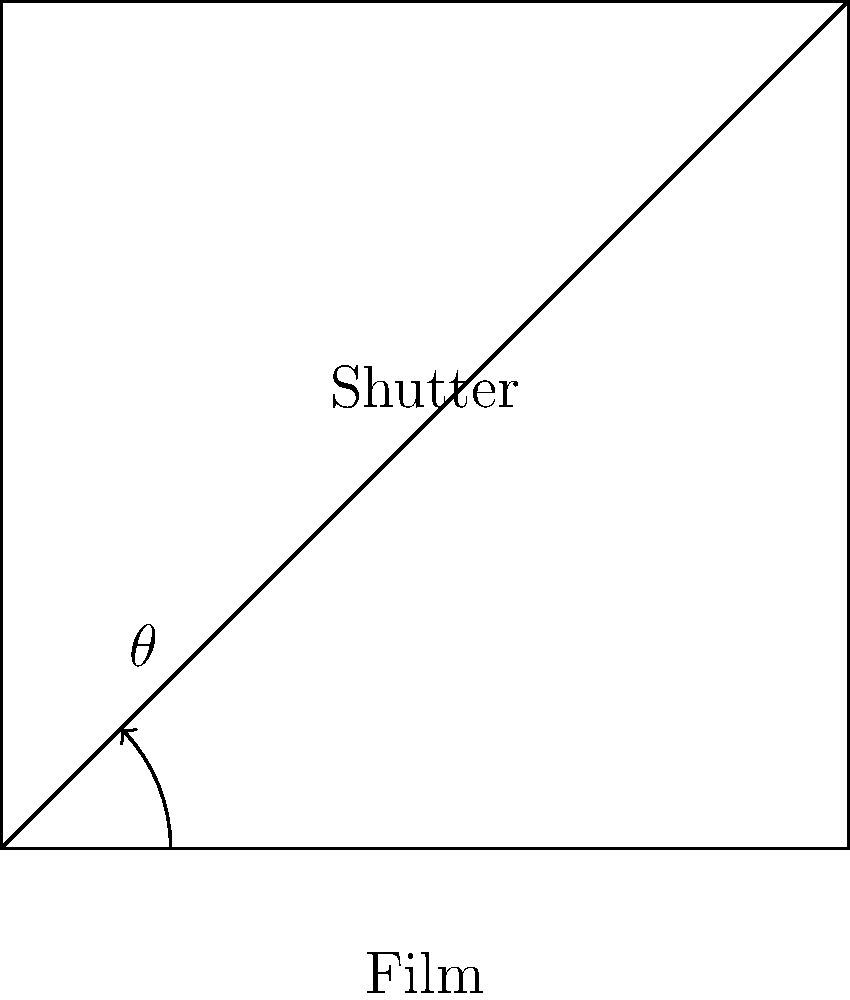In a focal plane shutter mechanism, the shutter angle $\theta$ is related to the exposure time. If the shutter completes a full rotation in 1/500th of a second, what is the exposure time in seconds when the shutter angle is set to 45°? To solve this problem, we need to follow these steps:

1. Understand that a full rotation of the shutter (360°) corresponds to 1/500th of a second.

2. Set up a proportion:
   $$\frac{360°}{1/500 \text{ s}} = \frac{45°}{x \text{ s}}$$

3. Cross multiply:
   $$360° \cdot x = 45° \cdot (1/500 \text{ s})$$

4. Solve for x:
   $$x = \frac{45° \cdot (1/500 \text{ s})}{360°}$$

5. Simplify:
   $$x = \frac{45}{360} \cdot \frac{1}{500} = \frac{1}{8} \cdot \frac{1}{500} = \frac{1}{4000} \text{ s}$$

Therefore, when the shutter angle is set to 45°, the exposure time is 1/4000th of a second.
Answer: 1/4000 s 